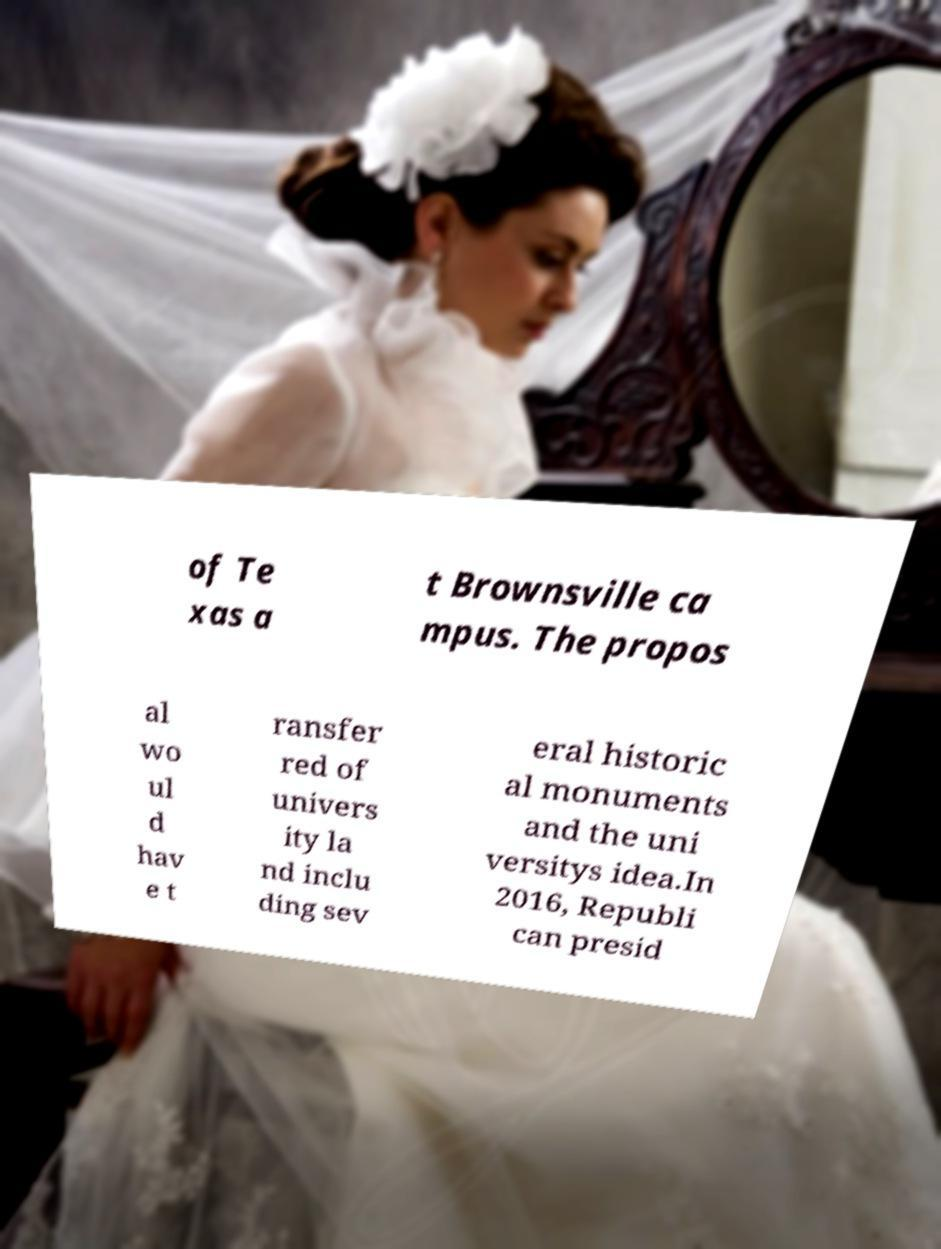I need the written content from this picture converted into text. Can you do that? of Te xas a t Brownsville ca mpus. The propos al wo ul d hav e t ransfer red of univers ity la nd inclu ding sev eral historic al monuments and the uni versitys idea.In 2016, Republi can presid 